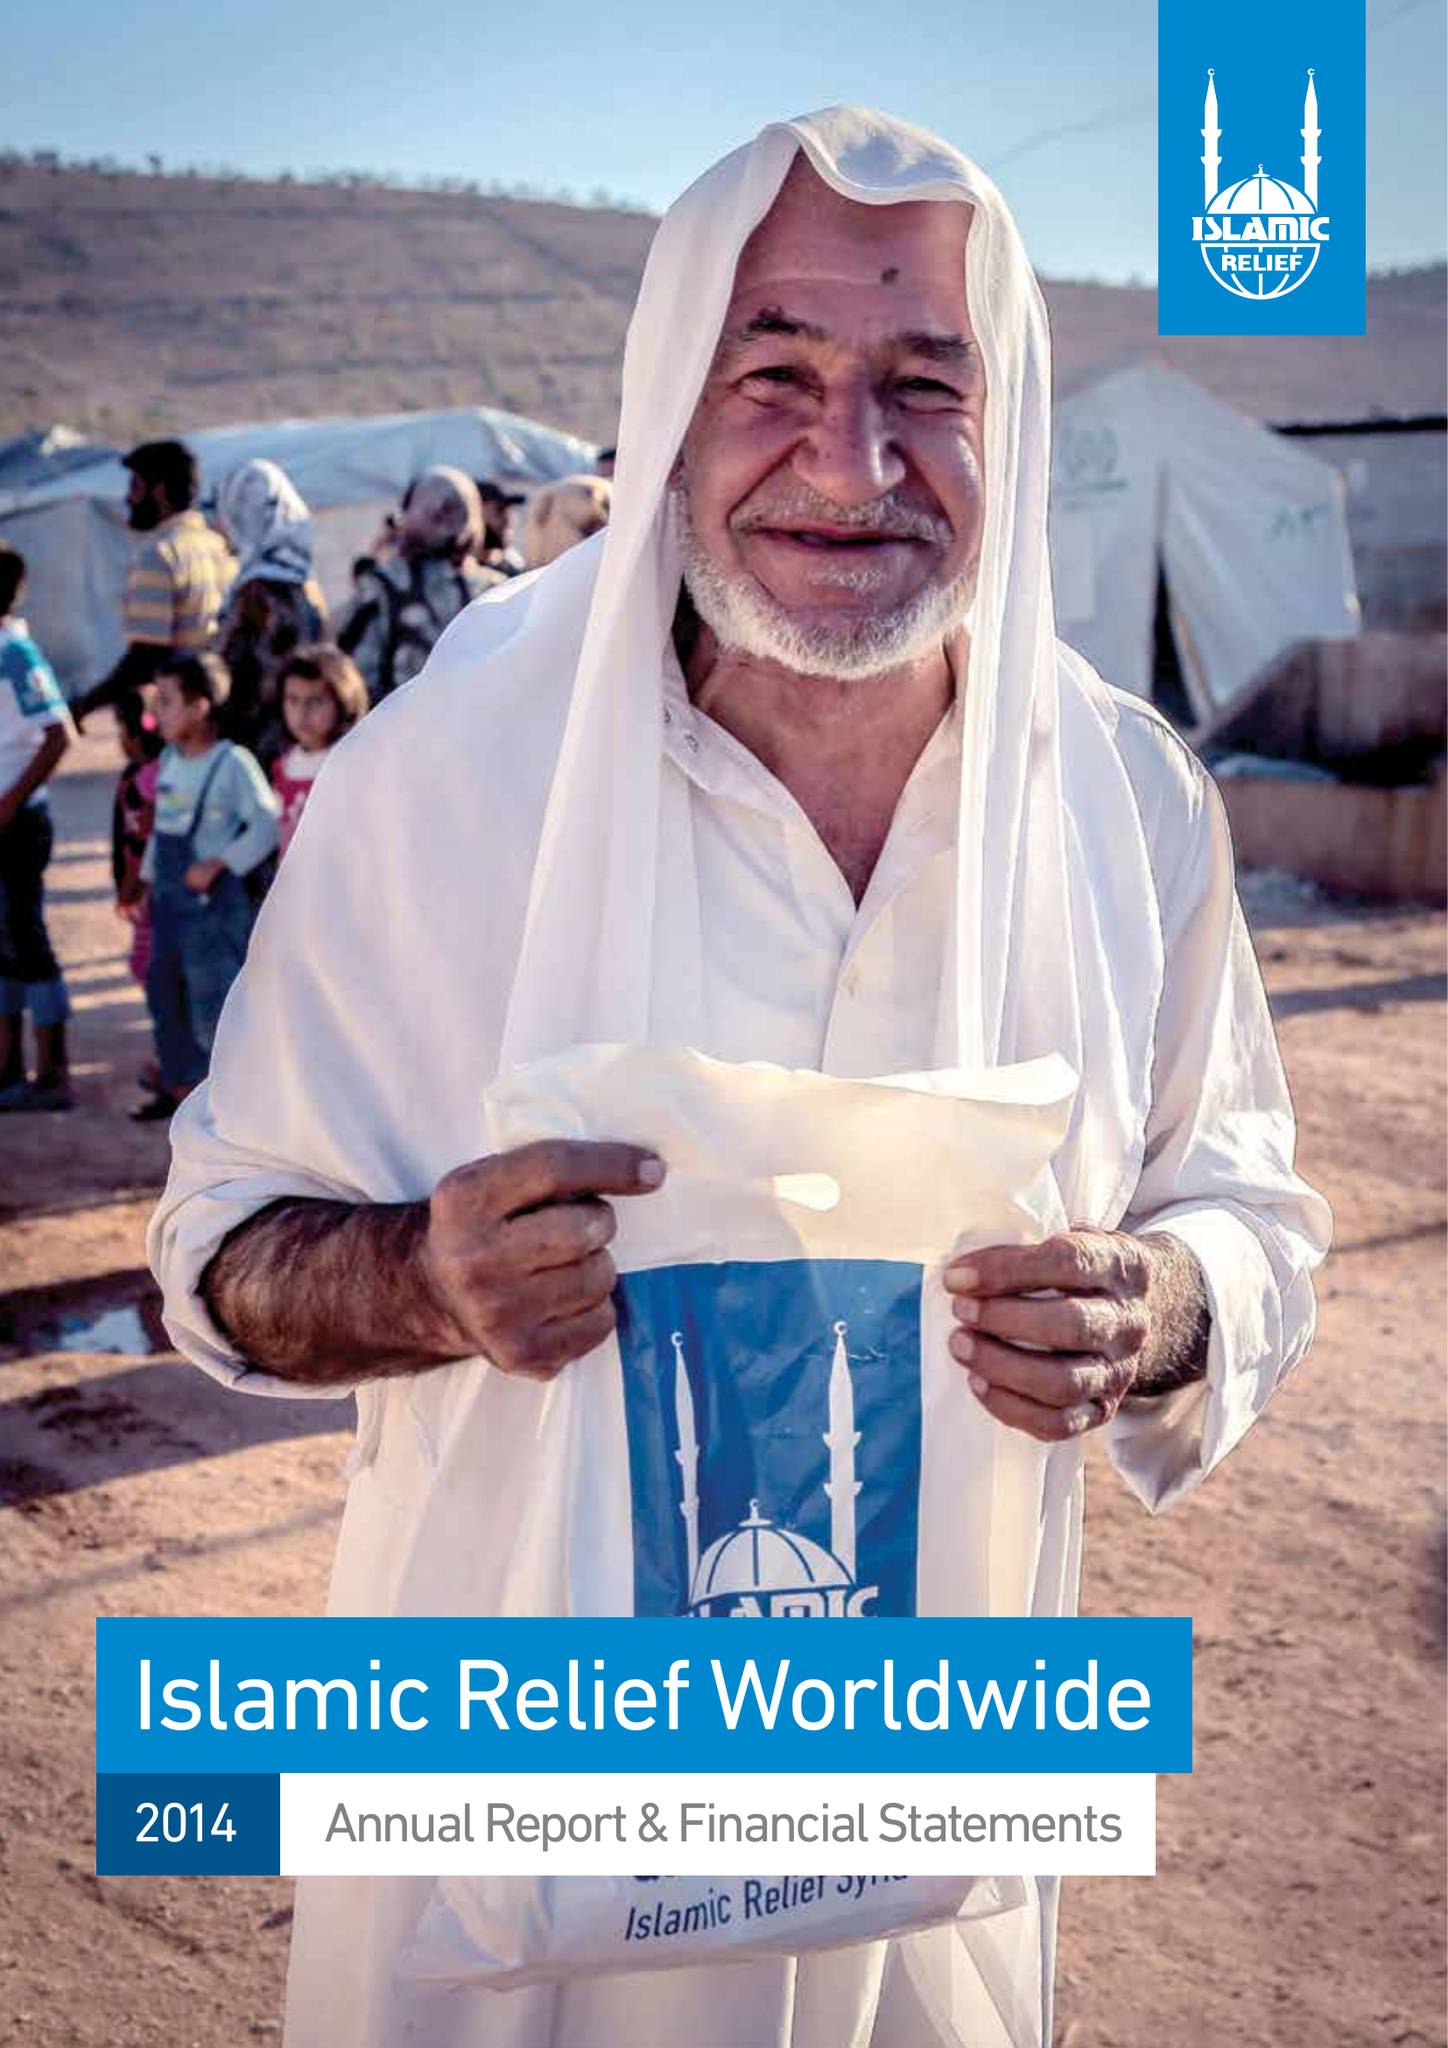What is the value for the address__postcode?
Answer the question using a single word or phrase. B5 6LB 